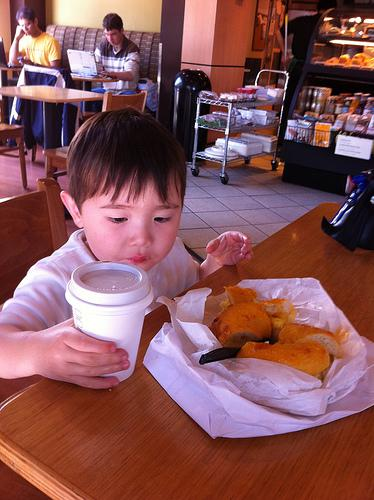Question: how is the boy?
Choices:
A. Standing.
B. Bent over.
C. Jumping.
D. Seated.
Answer with the letter. Answer: D Question: where is this scene?
Choices:
A. In a restaurant.
B. On splash mountain.
C. Grand Canyon.
D. Statue of Liberty.
Answer with the letter. Answer: A Question: who is this?
Choices:
A. Boy.
B. An old man.
C. A fat lady.
D. A big girl.
Answer with the letter. Answer: A Question: what is he holding?
Choices:
A. Phone.
B. Clock.
C. Food.
D. Cup.
Answer with the letter. Answer: D 